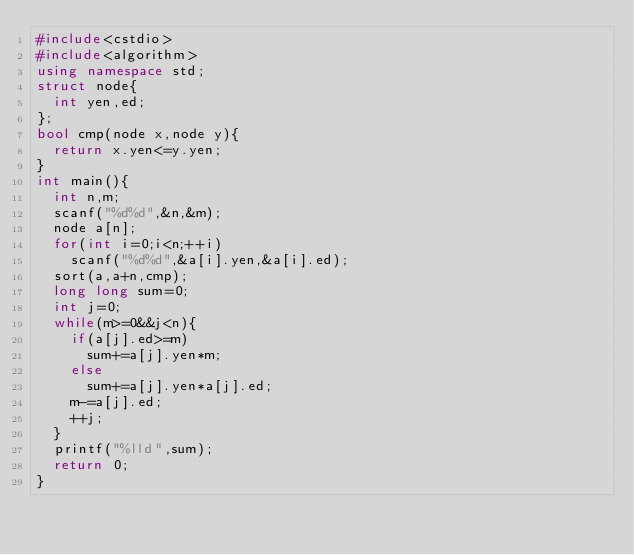<code> <loc_0><loc_0><loc_500><loc_500><_C++_>#include<cstdio>
#include<algorithm>
using namespace std;
struct node{
	int yen,ed;
};
bool cmp(node x,node y){
	return x.yen<=y.yen;
}
int main(){
	int n,m;
	scanf("%d%d",&n,&m);
	node a[n];
	for(int i=0;i<n;++i)
		scanf("%d%d",&a[i].yen,&a[i].ed);
	sort(a,a+n,cmp);
	long long sum=0;
	int j=0;
	while(m>=0&&j<n){
		if(a[j].ed>=m)
			sum+=a[j].yen*m;
		else
			sum+=a[j].yen*a[j].ed;
		m-=a[j].ed;
		++j;
	}
	printf("%lld",sum);
	return 0;
}</code> 